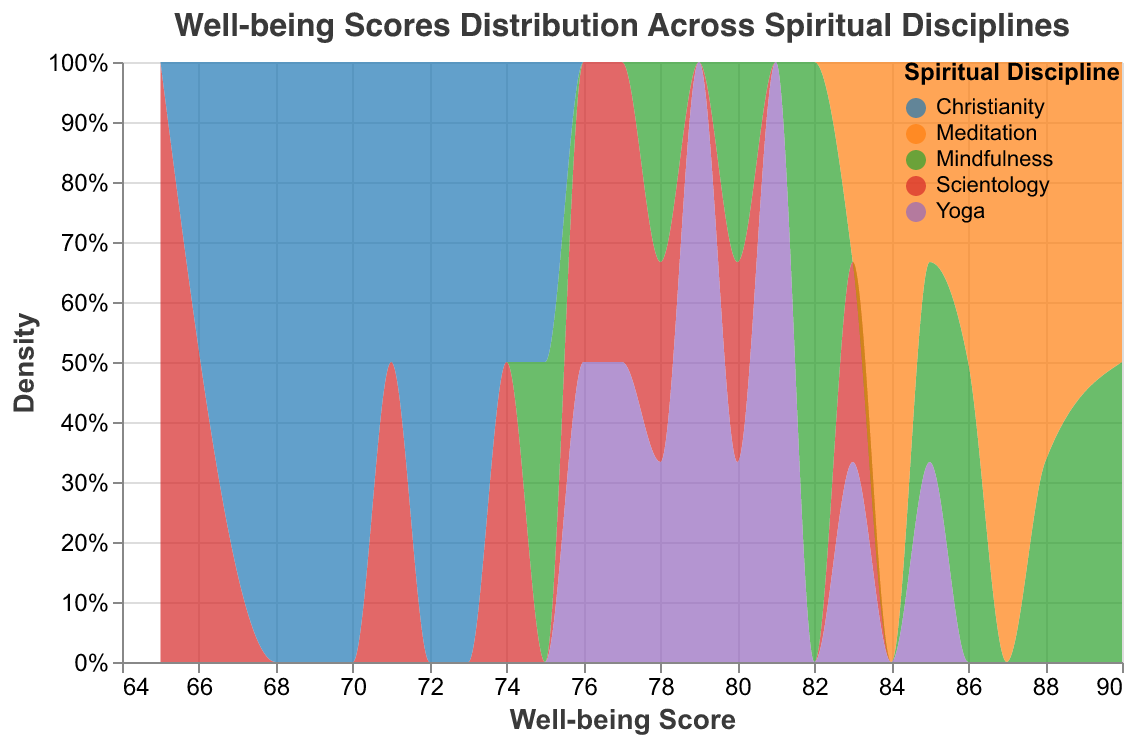What is the title of the figure? The title of the figure is found at the top center of the chart.
Answer: Well-being Scores Distribution Across Spiritual Disciplines How many spiritual disciplines are included in the data? By looking at the legend or the distinct colors in the chart, it shows the number of different spiritual disciplines represented.
Answer: Five Which discipline appears to have the highest density for well-being scores above 85? You can identify the area on the x-axis representing scores above 85 and see which discipline has the highest density in that area.
Answer: Meditation What is the well-being score range for Scientology participants? Observe the range that the colored area for Scientology spans along the x-axis.
Answer: 65 to 83 Between Mindfulness and Yoga, which discipline has a broader distribution of well-being scores? Compare the spread of the colored areas representing these disciplines along the x-axis; the broader the spread, the broader the distribution.
Answer: Mindfulness Which discipline has the lowest well-being score recorded in the dataset? Identify the discipline whose density plot extends to the lowest point on the x-axis.
Answer: Scientology How do the peak densities of Christianity and Yoga compare? Look at the highest points of their respective density plots; compare their heights to determine relative densities.
Answer: Yoga has a higher peak density than Christianity Which spiritual discipline has a well-being score distribution most consistently above 80? Determine which discipline has the majority of its density area concentrated above the score of 80 on the x-axis.
Answer: Meditation What is the approximate well-being score that the peak density of Scientology is centered around? Identify the highest point on the Scientology density plot and note the corresponding score on the x-axis.
Answer: Around 77 How does the well-being score distribution for Christianity compare to that of Mindfulness? Compare the range and shape of the density plots for Christianity and Mindfulness; note the spread and peak locations for each.
Answer: Christianity has a narrower and lower range than Mindfulness 